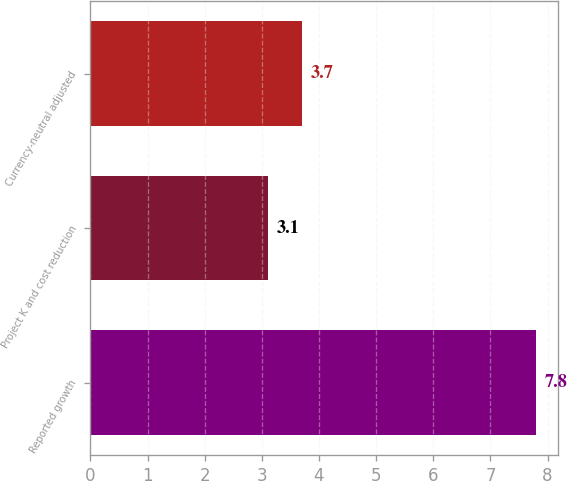<chart> <loc_0><loc_0><loc_500><loc_500><bar_chart><fcel>Reported growth<fcel>Project K and cost reduction<fcel>Currency-neutral adjusted<nl><fcel>7.8<fcel>3.1<fcel>3.7<nl></chart> 